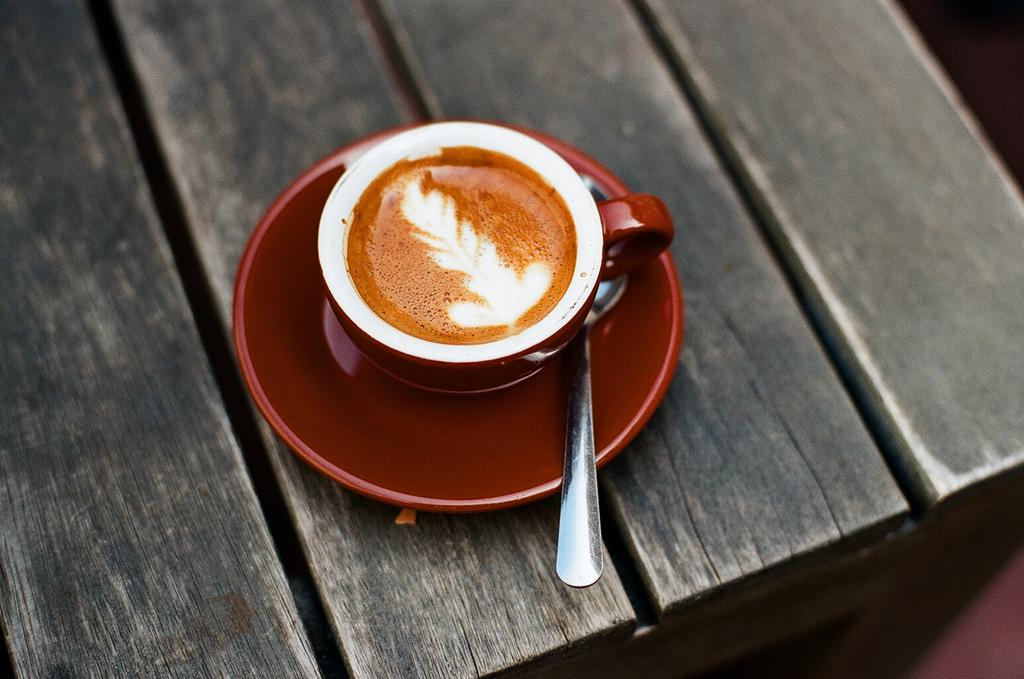What is in the cup that is visible in the image? There is a cup of coffee in the image. What is the cup resting on? The cup is on a saucer. What is the color of the saucer? The saucer is dark red in color. What utensil is present in the cup? There is a spoon in the cup. What type of stone is used to make the tent in the image? There is no tent present in the image, so it is not possible to determine what type of stone might be used. 